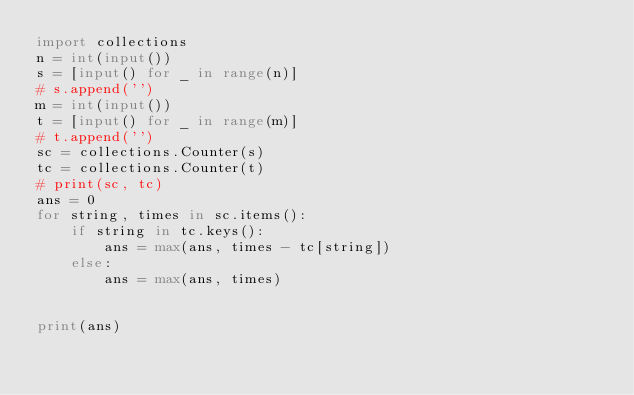<code> <loc_0><loc_0><loc_500><loc_500><_Python_>import collections
n = int(input())
s = [input() for _ in range(n)]
# s.append('')
m = int(input())
t = [input() for _ in range(m)]
# t.append('')
sc = collections.Counter(s)
tc = collections.Counter(t)
# print(sc, tc)
ans = 0
for string, times in sc.items():
    if string in tc.keys():
        ans = max(ans, times - tc[string])
    else:
        ans = max(ans, times)
        
        
print(ans)
</code> 